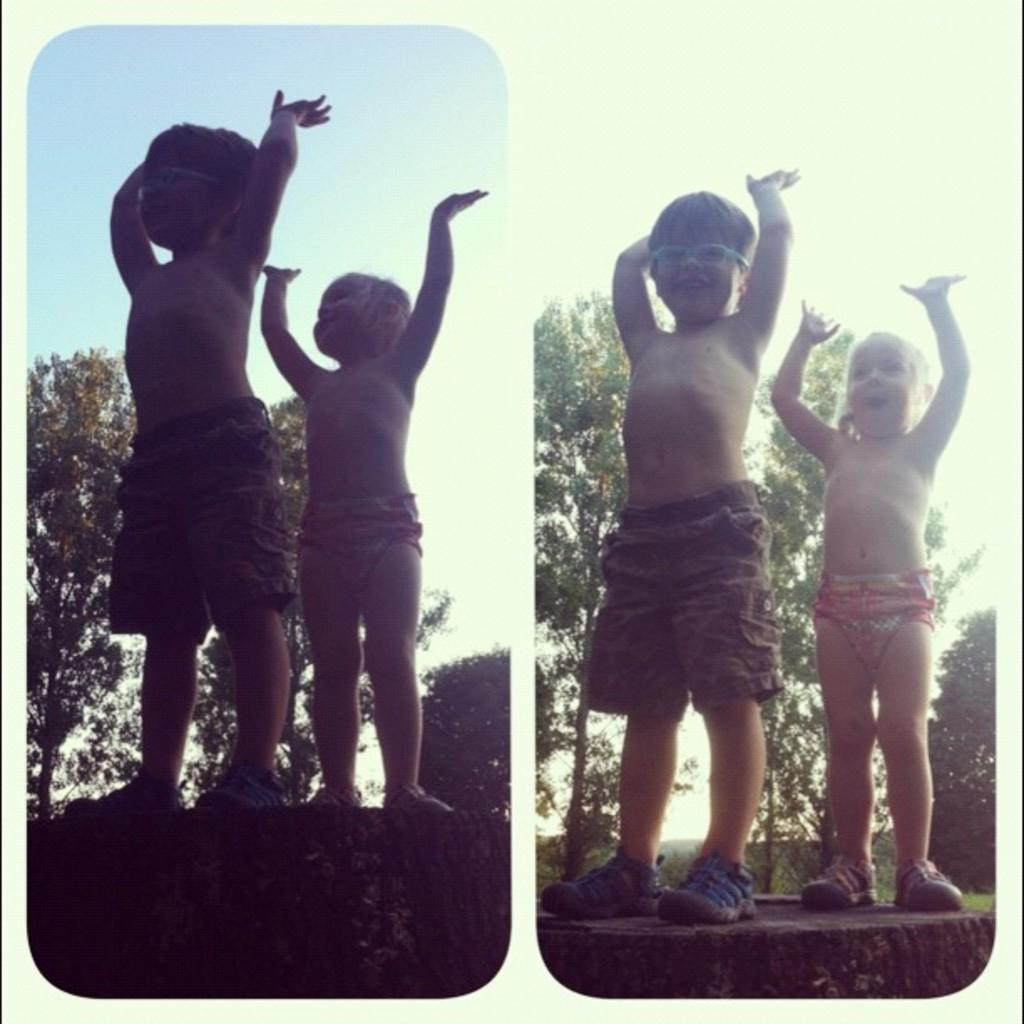What type of artwork is the image? The image is a collage. Who can be seen in the image? There are kids in the image. What are the kids wearing on their feet? The kids are wearing shoes. Where are the kids standing in the image? The kids are standing on a wall. Can you describe the boy in the image? The boy is in the image, and he is wearing goggles. What grade is the boy in the image? There is no information about the boy's grade in the image. Is the boy wearing a cast on his arm in the image? There is no cast visible on the boy's arm in the image. 